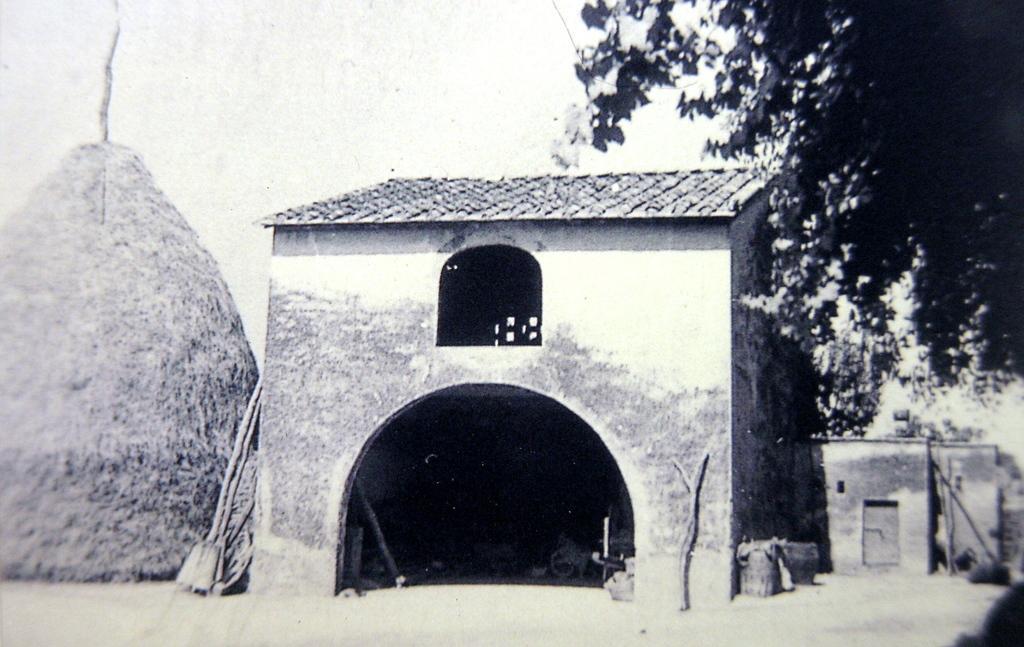How would you summarize this image in a sentence or two? This is a black and white picture. Here we can see a shed, hut, branches, and leaves. In the background there is sky. 